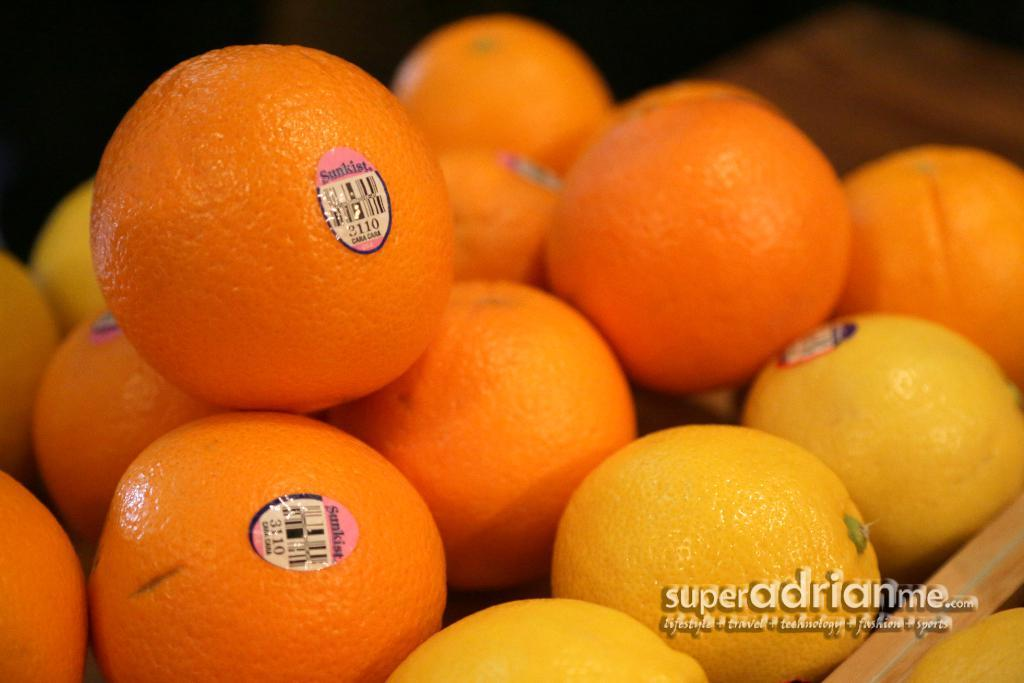What type of fruit is present in the image? There are oranges in the image. Is there any text visible in the image? Yes, there is some text at the bottom of the image. What type of footwear is visible in the image? There is no footwear present in the image; it only features oranges and text. What type of science experiment can be seen in the image? There is no science experiment present in the image; it only features oranges and text. 